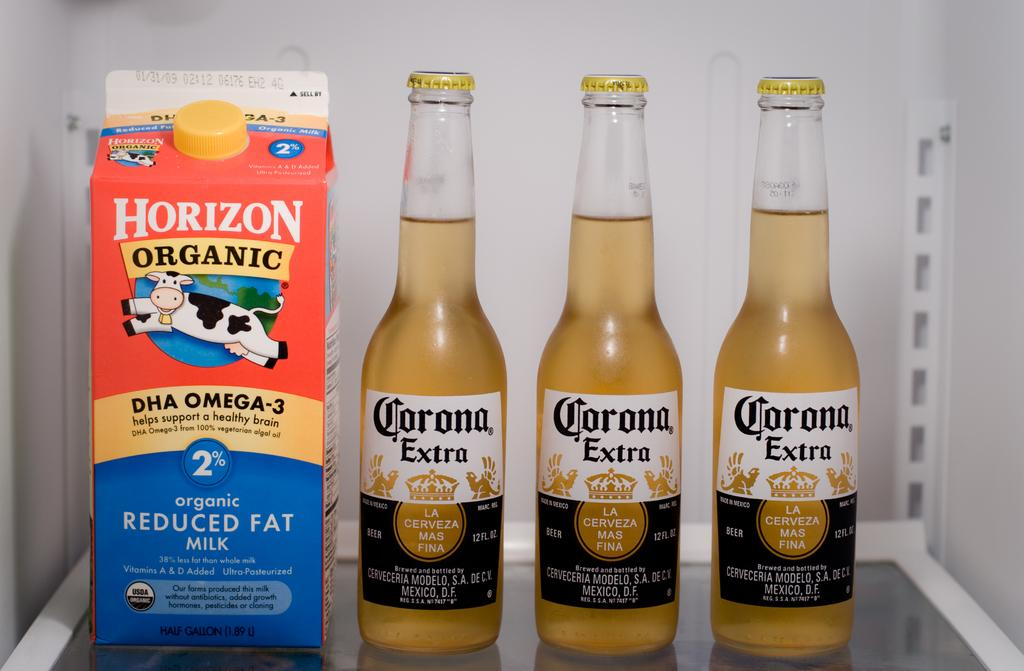<image>
Present a compact description of the photo's key features. Three bottles of Corona beer sit next to a quart of Horizon milk. 